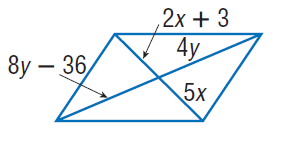Answer the mathemtical geometry problem and directly provide the correct option letter.
Question: Find x so that the quadrilateral is a parallelogram.
Choices: A: 1 B: 2 C: 4 D: 5 A 